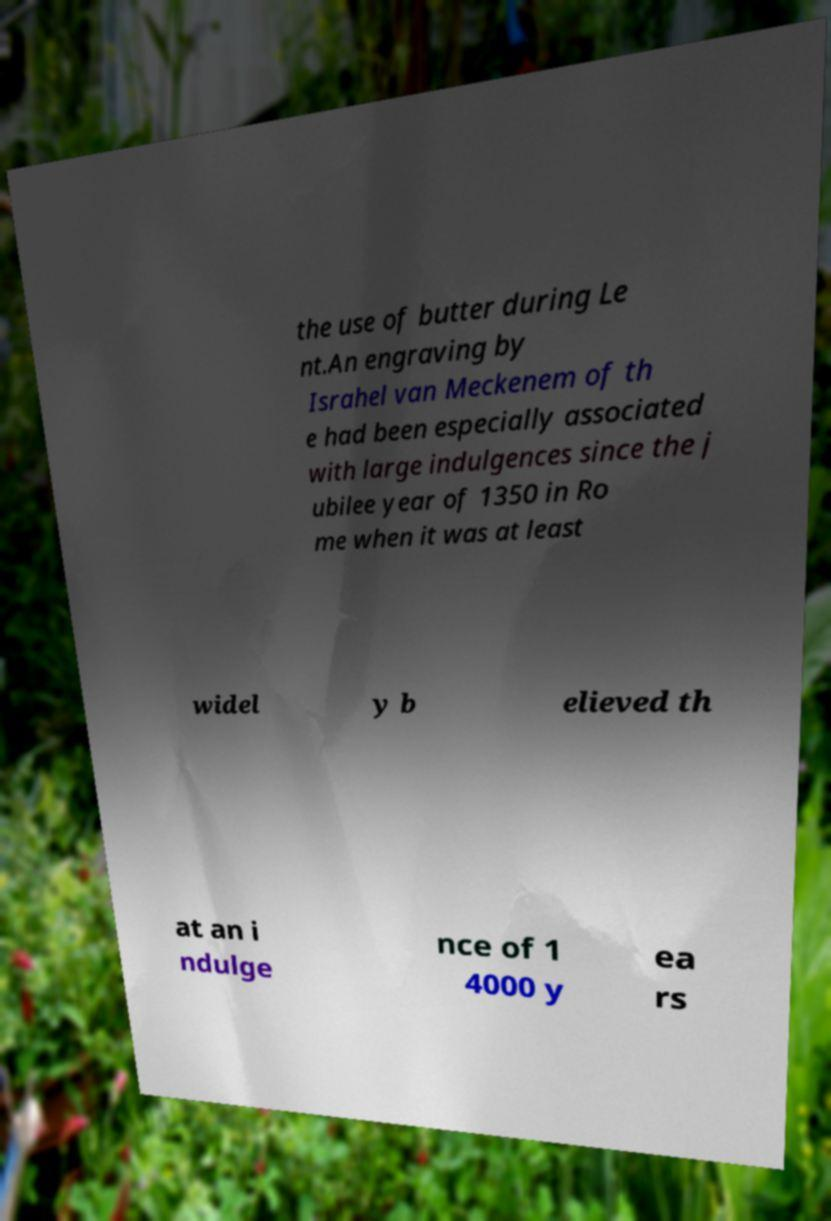Please read and relay the text visible in this image. What does it say? the use of butter during Le nt.An engraving by Israhel van Meckenem of th e had been especially associated with large indulgences since the j ubilee year of 1350 in Ro me when it was at least widel y b elieved th at an i ndulge nce of 1 4000 y ea rs 